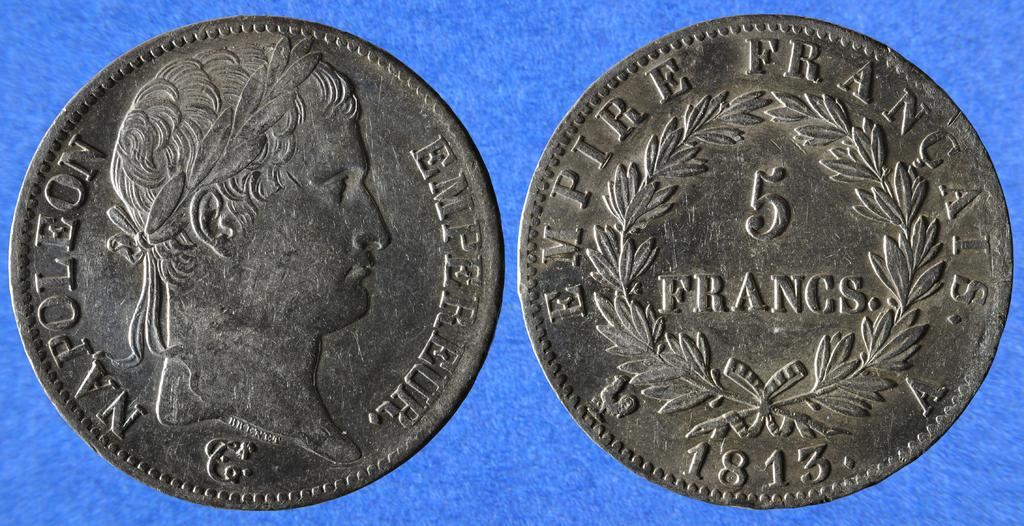<image>
Give a short and clear explanation of the subsequent image. The head and tails of a Napoleon 5 Francs coin from 1813 